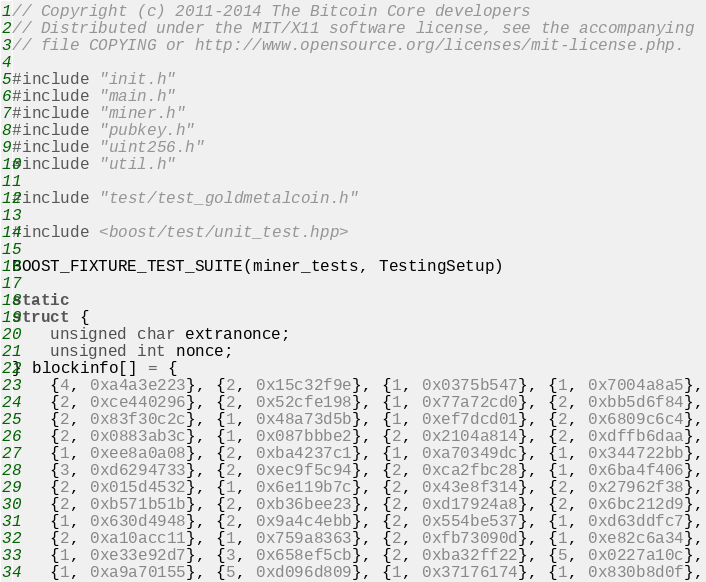Convert code to text. <code><loc_0><loc_0><loc_500><loc_500><_C++_>// Copyright (c) 2011-2014 The Bitcoin Core developers
// Distributed under the MIT/X11 software license, see the accompanying
// file COPYING or http://www.opensource.org/licenses/mit-license.php.

#include "init.h"
#include "main.h"
#include "miner.h"
#include "pubkey.h"
#include "uint256.h"
#include "util.h"

#include "test/test_goldmetalcoin.h"

#include <boost/test/unit_test.hpp>

BOOST_FIXTURE_TEST_SUITE(miner_tests, TestingSetup)

static
struct {
    unsigned char extranonce;
    unsigned int nonce;
} blockinfo[] = {
    {4, 0xa4a3e223}, {2, 0x15c32f9e}, {1, 0x0375b547}, {1, 0x7004a8a5},
    {2, 0xce440296}, {2, 0x52cfe198}, {1, 0x77a72cd0}, {2, 0xbb5d6f84},
    {2, 0x83f30c2c}, {1, 0x48a73d5b}, {1, 0xef7dcd01}, {2, 0x6809c6c4},
    {2, 0x0883ab3c}, {1, 0x087bbbe2}, {2, 0x2104a814}, {2, 0xdffb6daa},
    {1, 0xee8a0a08}, {2, 0xba4237c1}, {1, 0xa70349dc}, {1, 0x344722bb},
    {3, 0xd6294733}, {2, 0xec9f5c94}, {2, 0xca2fbc28}, {1, 0x6ba4f406},
    {2, 0x015d4532}, {1, 0x6e119b7c}, {2, 0x43e8f314}, {2, 0x27962f38},
    {2, 0xb571b51b}, {2, 0xb36bee23}, {2, 0xd17924a8}, {2, 0x6bc212d9},
    {1, 0x630d4948}, {2, 0x9a4c4ebb}, {2, 0x554be537}, {1, 0xd63ddfc7},
    {2, 0xa10acc11}, {1, 0x759a8363}, {2, 0xfb73090d}, {1, 0xe82c6a34},
    {1, 0xe33e92d7}, {3, 0x658ef5cb}, {2, 0xba32ff22}, {5, 0x0227a10c},
    {1, 0xa9a70155}, {5, 0xd096d809}, {1, 0x37176174}, {1, 0x830b8d0f},</code> 